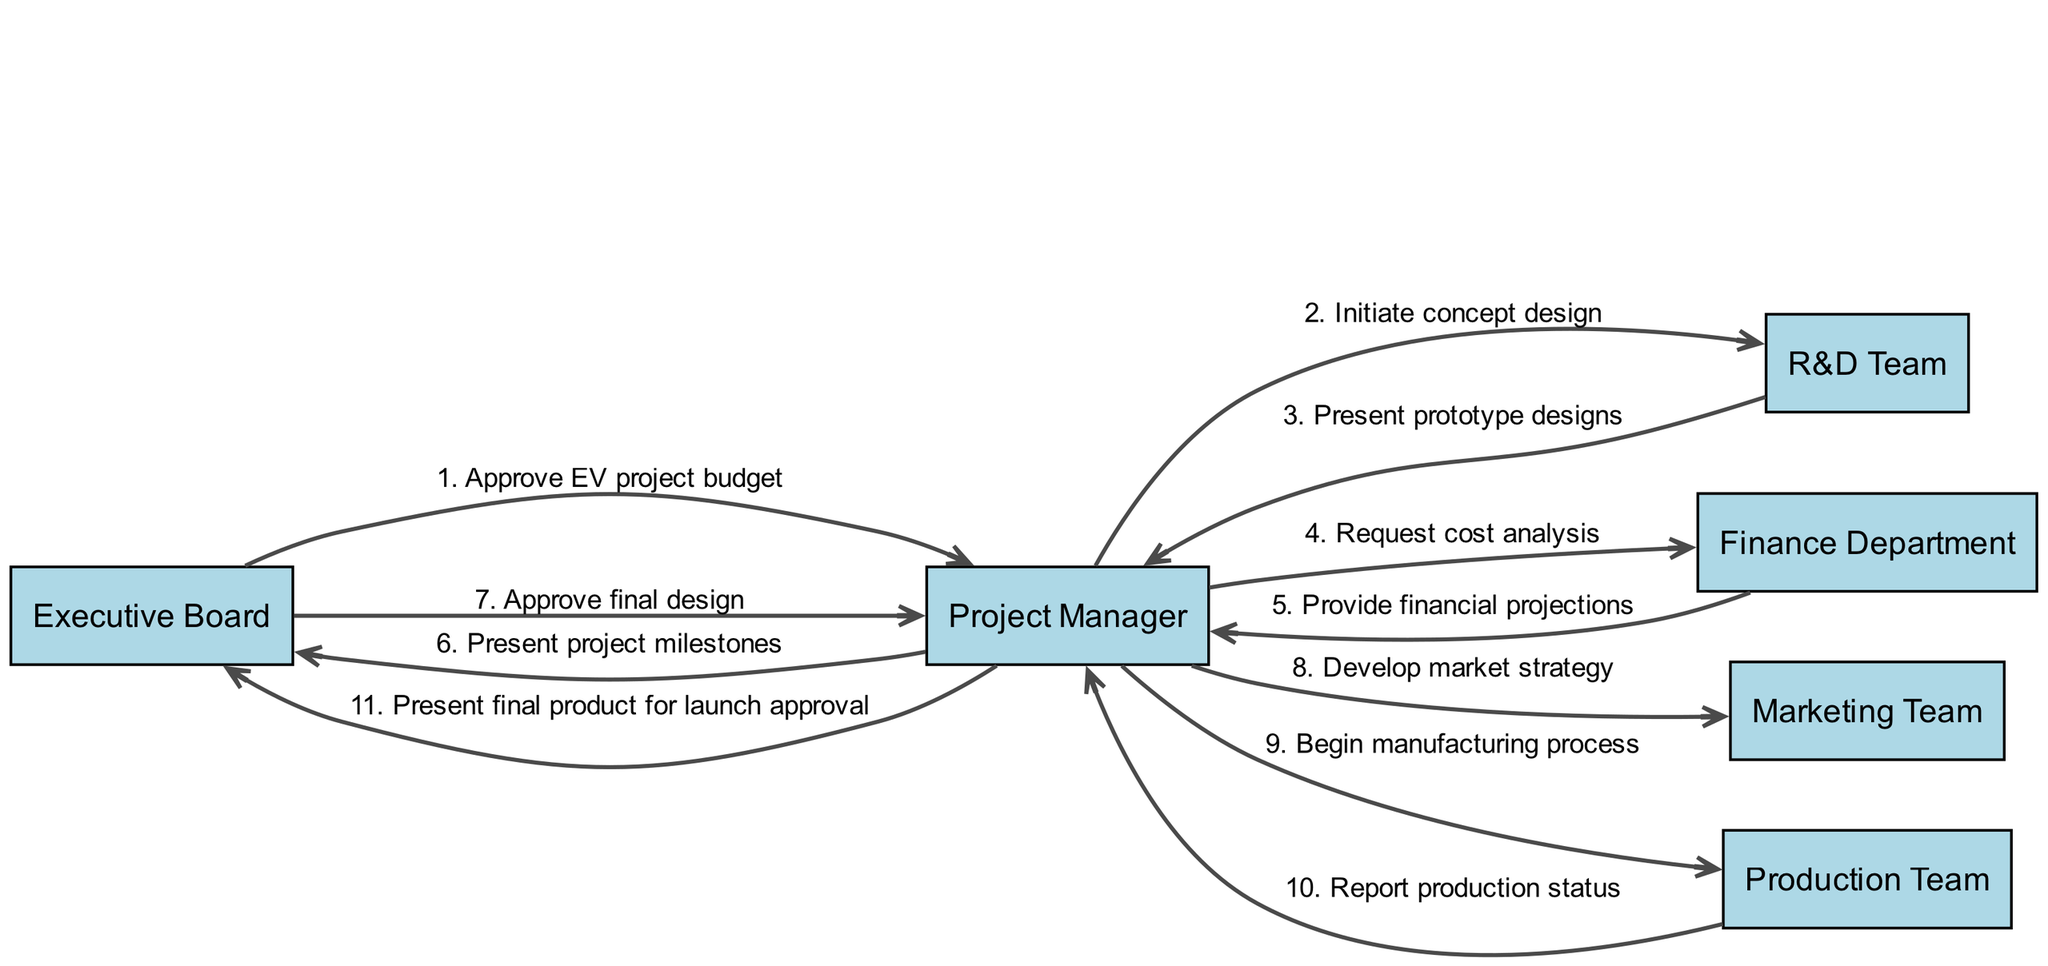What is the first action in the diagram? The first action involves the Executive Board sending a message to the Project Manager, specifically "Approve EV project budget". This is the initiating action in the product development lifecycle.
Answer: Approve EV project budget How many actors are in the diagram? The diagram contains a total of six actors: Executive Board, Project Manager, R&D Team, Finance Department, Marketing Team, and Production Team. These actors represent different roles in the project lifecycle.
Answer: 6 What message does the Finance Department send to the Project Manager? The Finance Department responds to the Project Manager's request by providing "Provide financial projections". This message reflects a critical stage in evaluating the project's viability.
Answer: Provide financial projections Which team develops the market strategy? The Market strategy is developed by the Marketing Team, as shown when the Project Manager communicates this task to them in the sequence.
Answer: Marketing Team What is the last action in the sequence? The last action in the sequence is the Project Manager presenting the final product for launch approval to the Executive Board. This step is crucial for moving forward to market the product.
Answer: Present final product for launch approval How many messages are sent from the Project Manager to other actors? The Project Manager sends a total of four messages to other actors throughout the sequence. Specifically, they communicate with the R&D Team, Finance Department, Marketing Team, and Production Team.
Answer: 4 What actor does the R&D Team present prototype designs to? The R&D Team presents the prototype designs to the Project Manager as part of the communication flow in the development process.
Answer: Project Manager What is the purpose of the communication between the Production Team and the Project Manager? The Production Team reports production status to the Project Manager, serving to update them on the progress and challenges faced during manufacturing.
Answer: Report production status Which team is asked to begin the manufacturing process? The Production Team is instructed to begin the manufacturing process by the Project Manager, which is a crucial step in the lifecycle of product development.
Answer: Production Team 